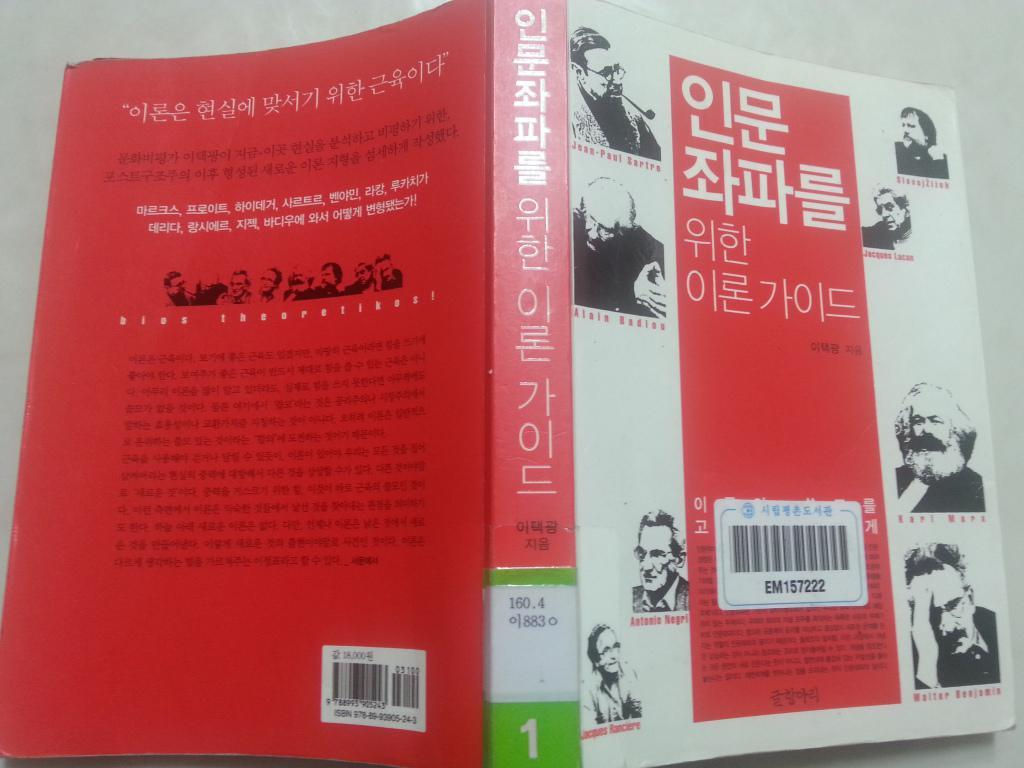<image>
Render a clear and concise summary of the photo. A red and white book with Asian writing on it. 